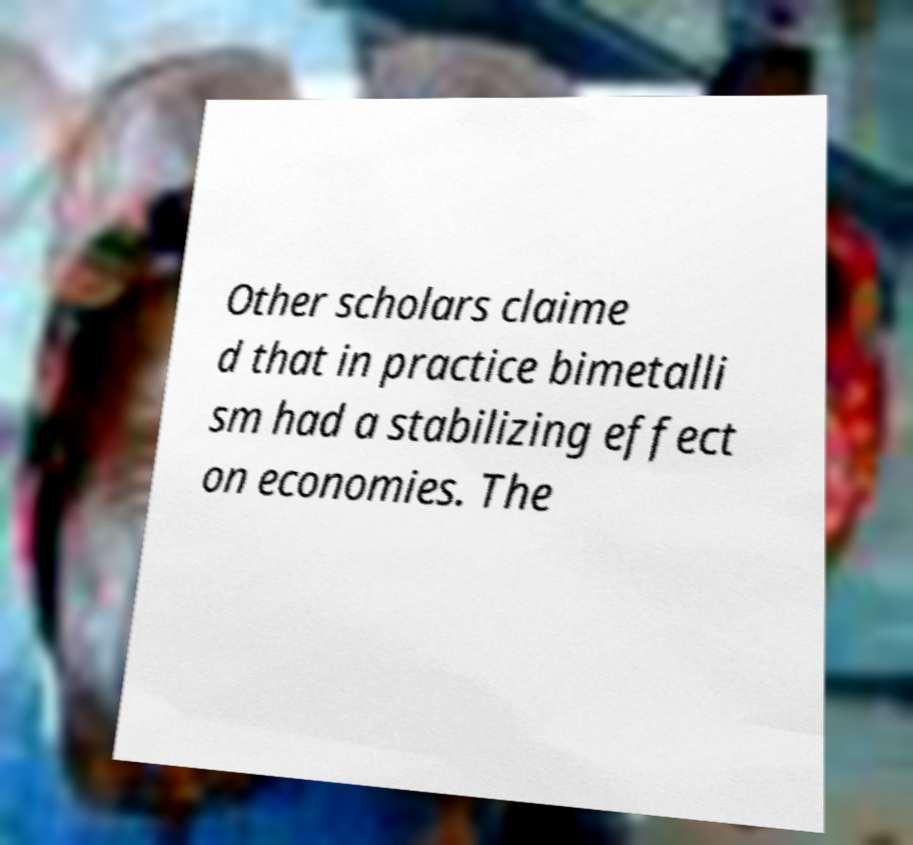Can you accurately transcribe the text from the provided image for me? Other scholars claime d that in practice bimetalli sm had a stabilizing effect on economies. The 